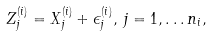Convert formula to latex. <formula><loc_0><loc_0><loc_500><loc_500>Z _ { j } ^ { ( i ) } = X _ { j } ^ { ( i ) } + \epsilon _ { j } ^ { ( i ) } , \, j = 1 , \dots n _ { i } ,</formula> 